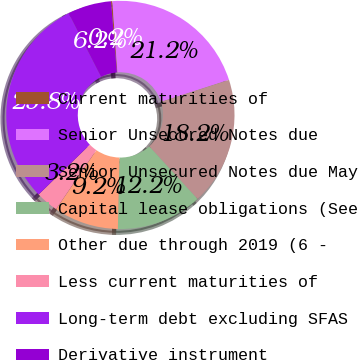Convert chart. <chart><loc_0><loc_0><loc_500><loc_500><pie_chart><fcel>Current maturities of<fcel>Senior Unsecured Notes due<fcel>Senior Unsecured Notes due May<fcel>Capital lease obligations (See<fcel>Other due through 2019 (6 -<fcel>Less current maturities of<fcel>Long-term debt excluding SFAS<fcel>Derivative instrument<nl><fcel>0.19%<fcel>21.16%<fcel>18.16%<fcel>12.17%<fcel>9.18%<fcel>3.19%<fcel>29.78%<fcel>6.18%<nl></chart> 